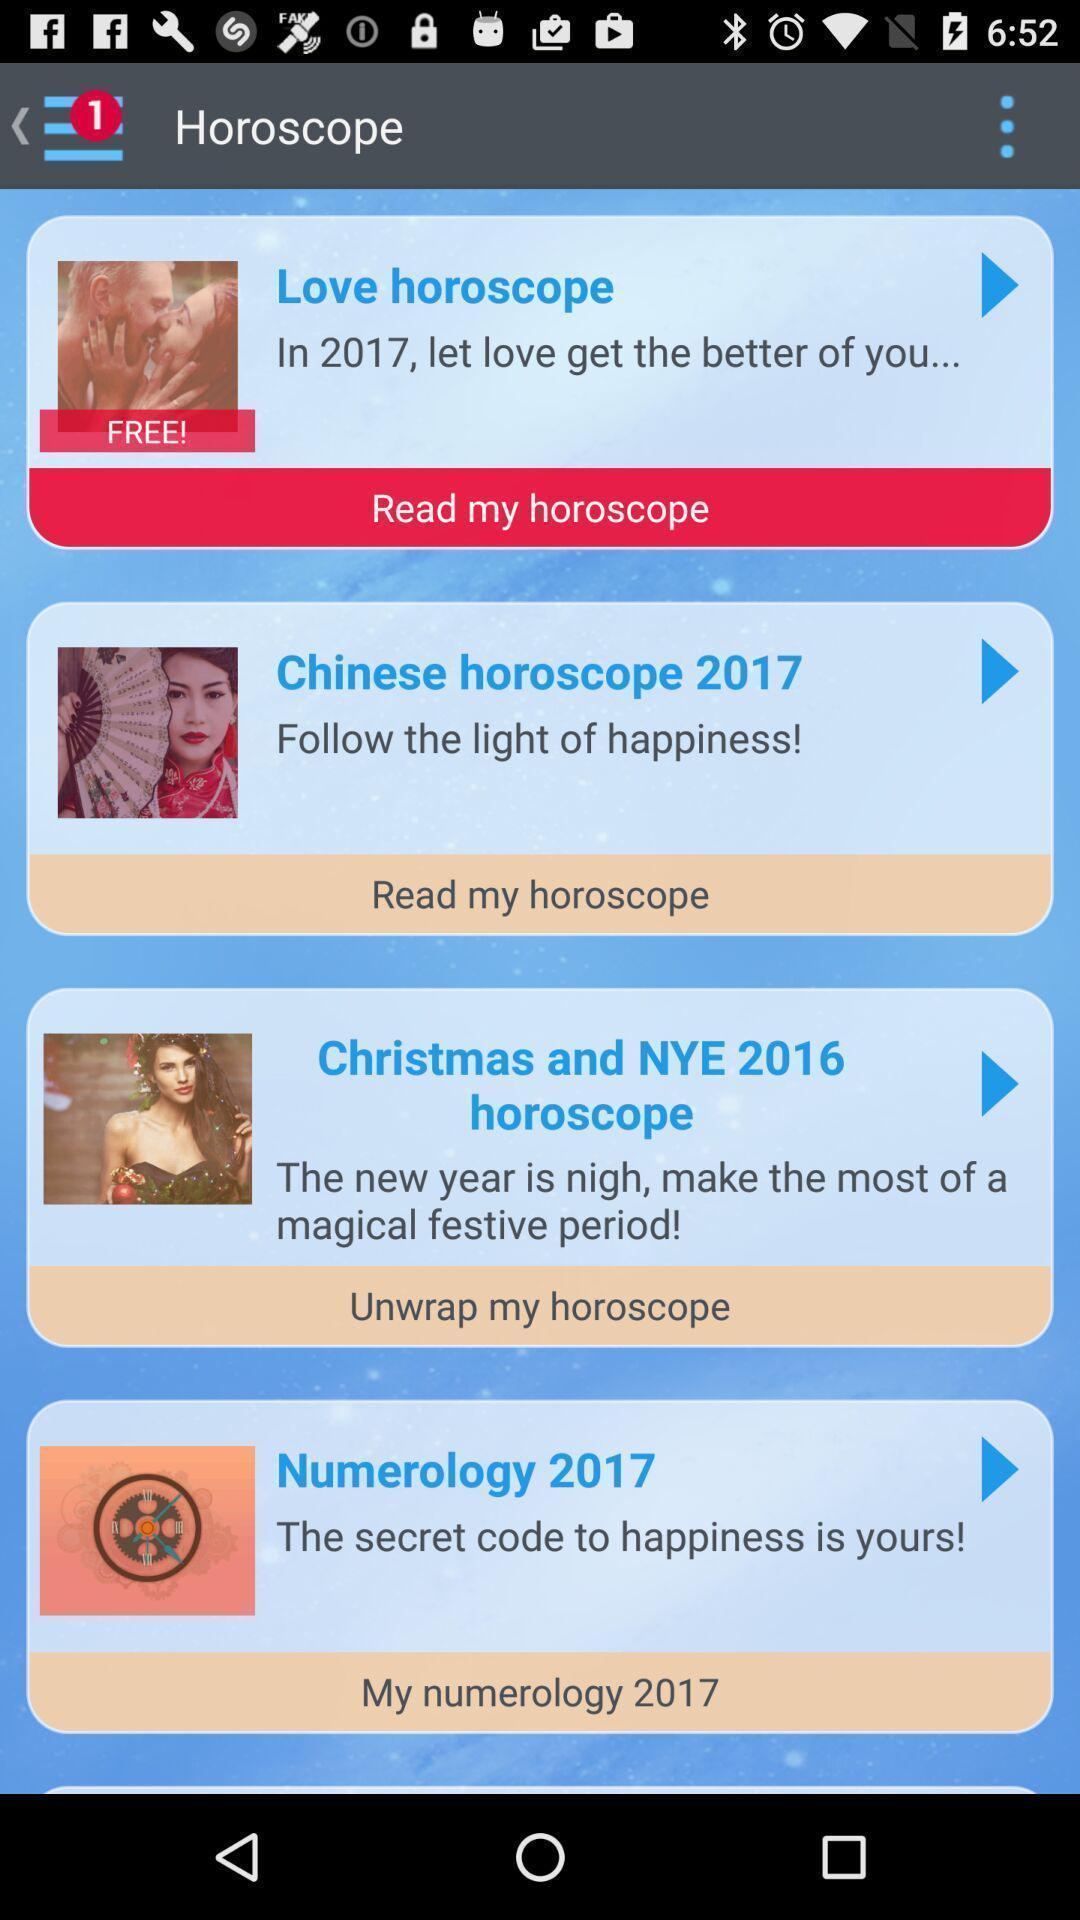Describe the key features of this screenshot. Page displaying to read horoscope. 